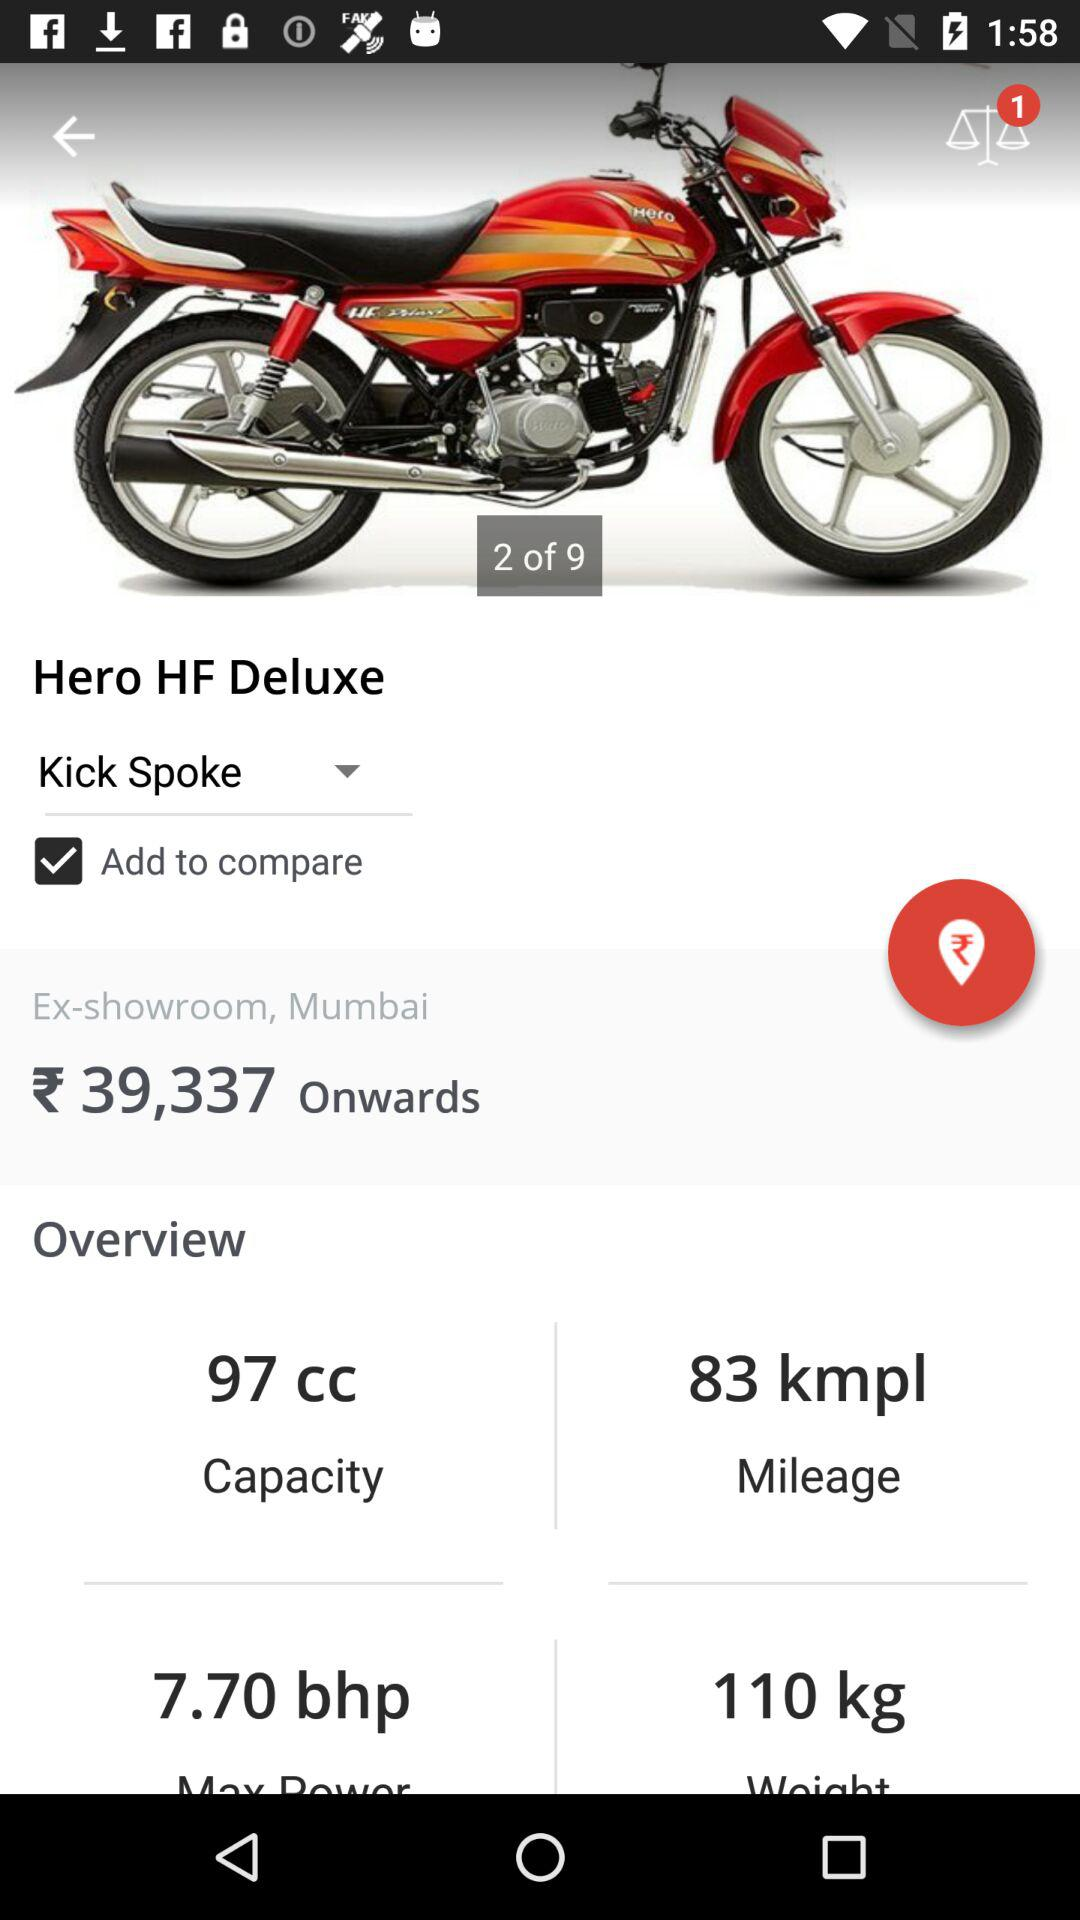What is the capacity of the bike? The capacity of the bike is 97 cc. 